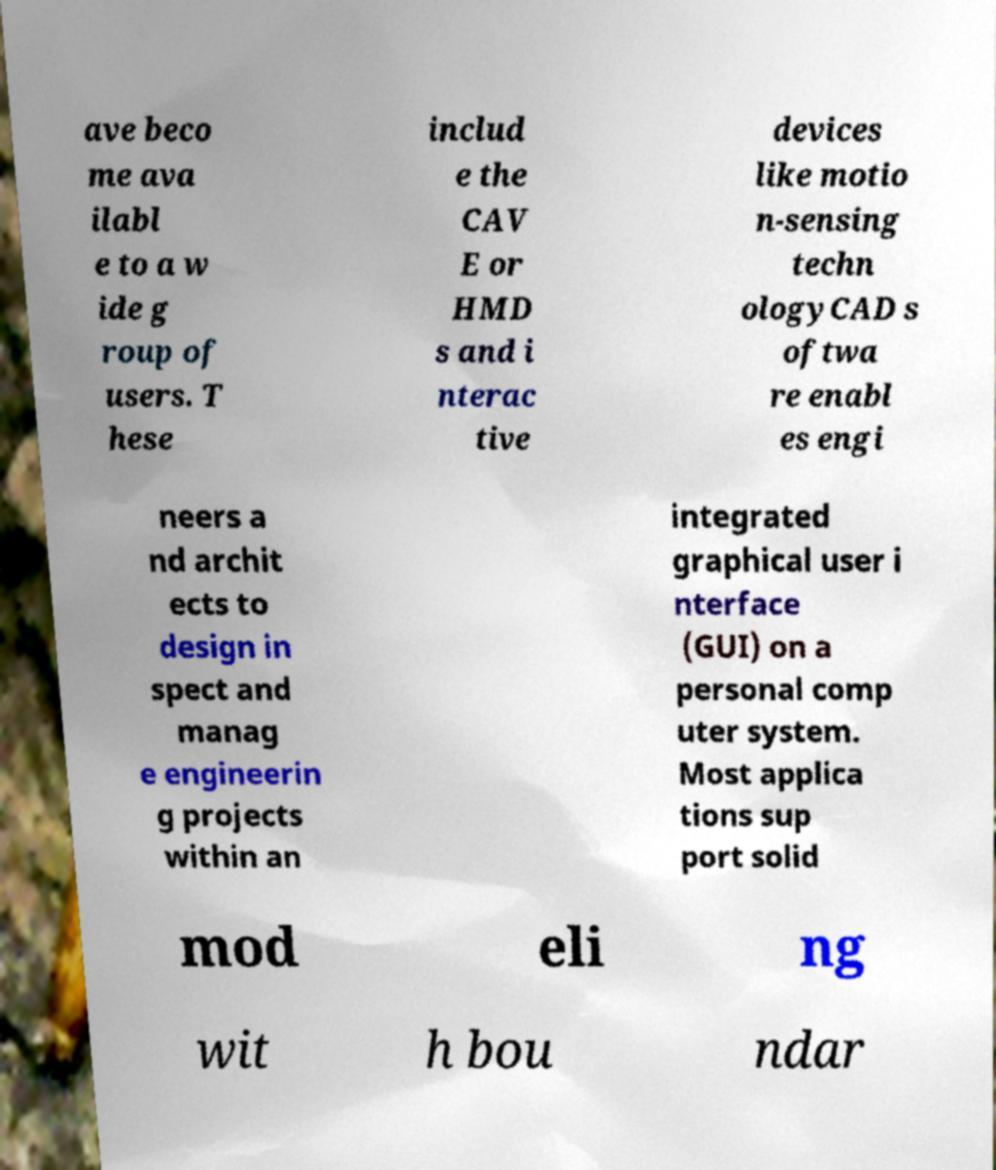There's text embedded in this image that I need extracted. Can you transcribe it verbatim? ave beco me ava ilabl e to a w ide g roup of users. T hese includ e the CAV E or HMD s and i nterac tive devices like motio n-sensing techn ologyCAD s oftwa re enabl es engi neers a nd archit ects to design in spect and manag e engineerin g projects within an integrated graphical user i nterface (GUI) on a personal comp uter system. Most applica tions sup port solid mod eli ng wit h bou ndar 